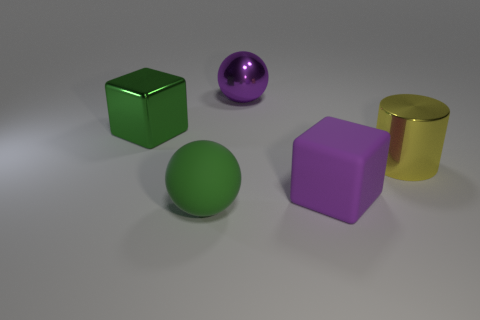Add 1 large green metallic things. How many objects exist? 6 Subtract all cylinders. How many objects are left? 4 Subtract all green matte spheres. Subtract all yellow metallic things. How many objects are left? 3 Add 2 large green rubber things. How many large green rubber things are left? 3 Add 4 big green rubber spheres. How many big green rubber spheres exist? 5 Subtract 0 gray cubes. How many objects are left? 5 